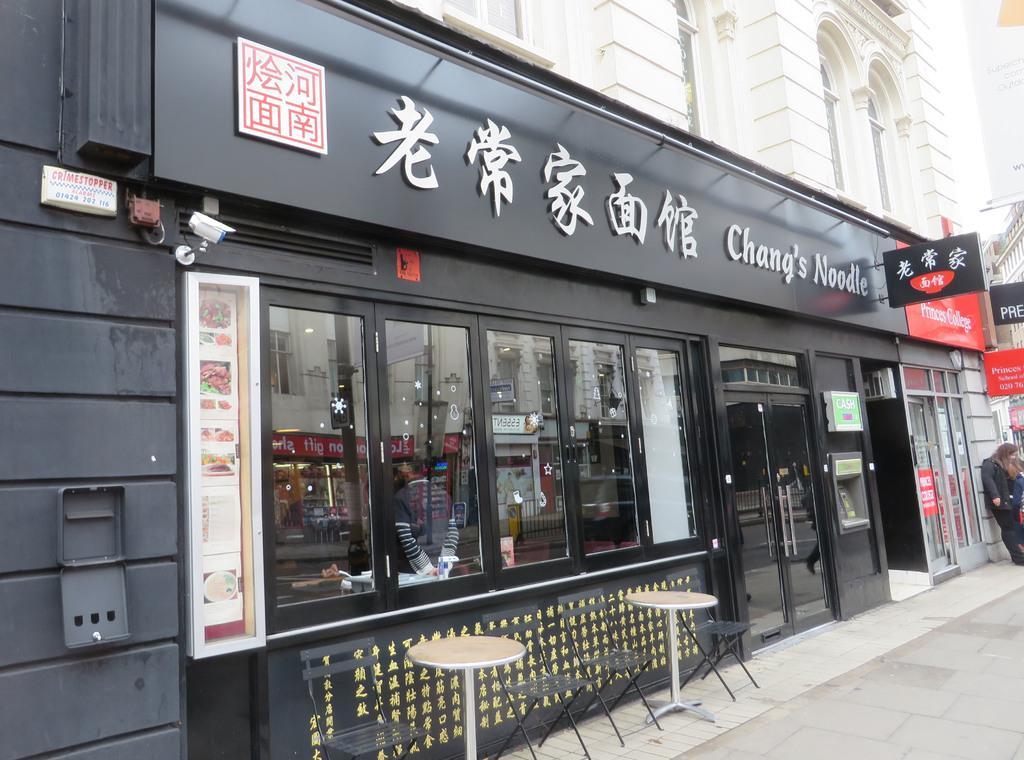How would you summarize this image in a sentence or two? In this image there is a building having few boards attached to the wall. There are windows and doors to the wall. Few chairs and tables are on the pavement. Right side a person is standing on the pavement. From the window a person and few objects are visible. On the window there is a reflection of a building. 